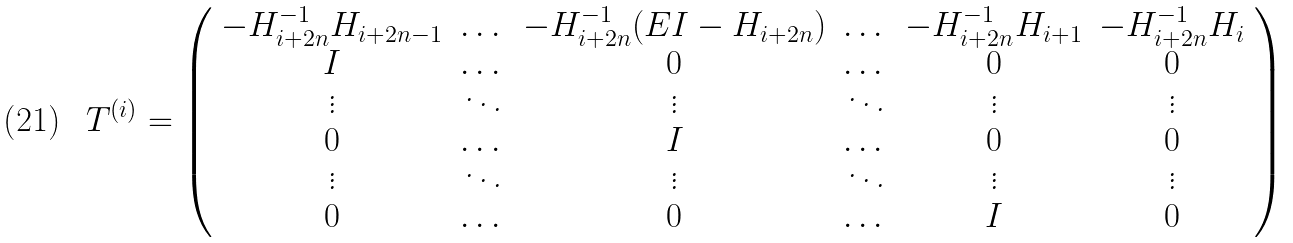Convert formula to latex. <formula><loc_0><loc_0><loc_500><loc_500>T ^ { ( i ) } = \left ( \begin{array} { c c c c c c } - H _ { i + 2 n } ^ { - 1 } H _ { i + 2 n - 1 } & \dots & - H _ { i + 2 n } ^ { - 1 } ( E I - H _ { i + 2 n } ) & \dots & - H _ { i + 2 n } ^ { - 1 } H _ { i + 1 } & - H _ { i + 2 n } ^ { - 1 } H _ { i } \\ I & \dots & 0 & \dots & 0 & 0 \\ \vdots & \ddots & \vdots & \ddots & \vdots & \vdots \\ 0 & \dots & I & \dots & 0 & 0 \\ \vdots & \ddots & \vdots & \ddots & \vdots & \vdots \\ 0 & \dots & 0 & \dots & I & 0 \end{array} \right )</formula> 